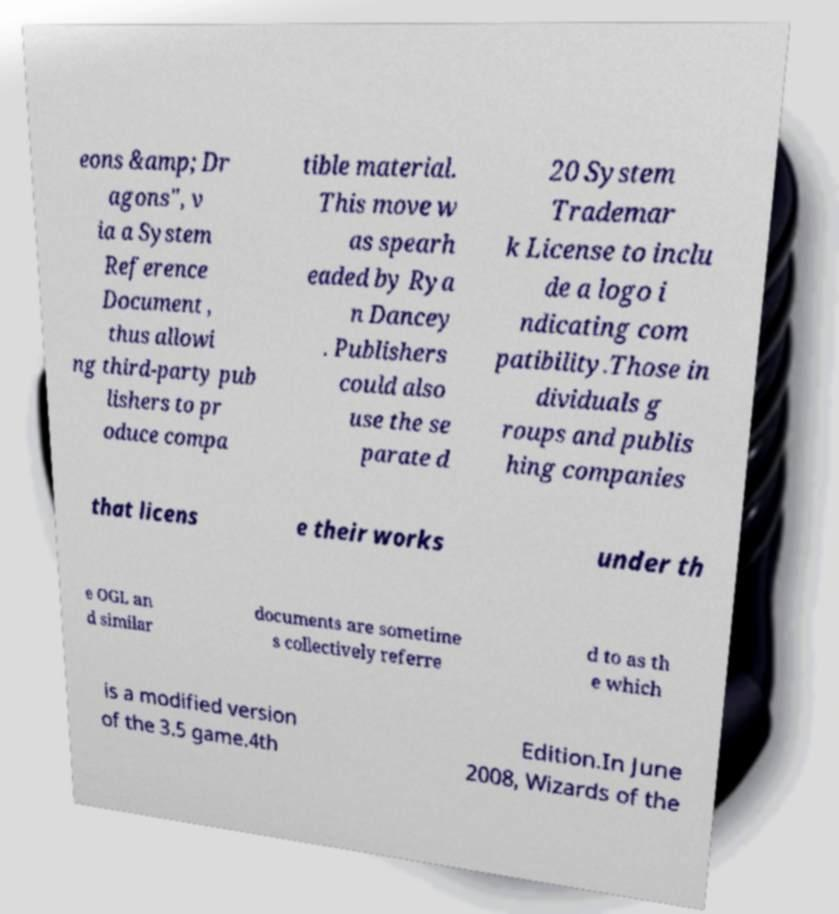Could you assist in decoding the text presented in this image and type it out clearly? eons &amp; Dr agons", v ia a System Reference Document , thus allowi ng third-party pub lishers to pr oduce compa tible material. This move w as spearh eaded by Rya n Dancey . Publishers could also use the se parate d 20 System Trademar k License to inclu de a logo i ndicating com patibility.Those in dividuals g roups and publis hing companies that licens e their works under th e OGL an d similar documents are sometime s collectively referre d to as th e which is a modified version of the 3.5 game.4th Edition.In June 2008, Wizards of the 